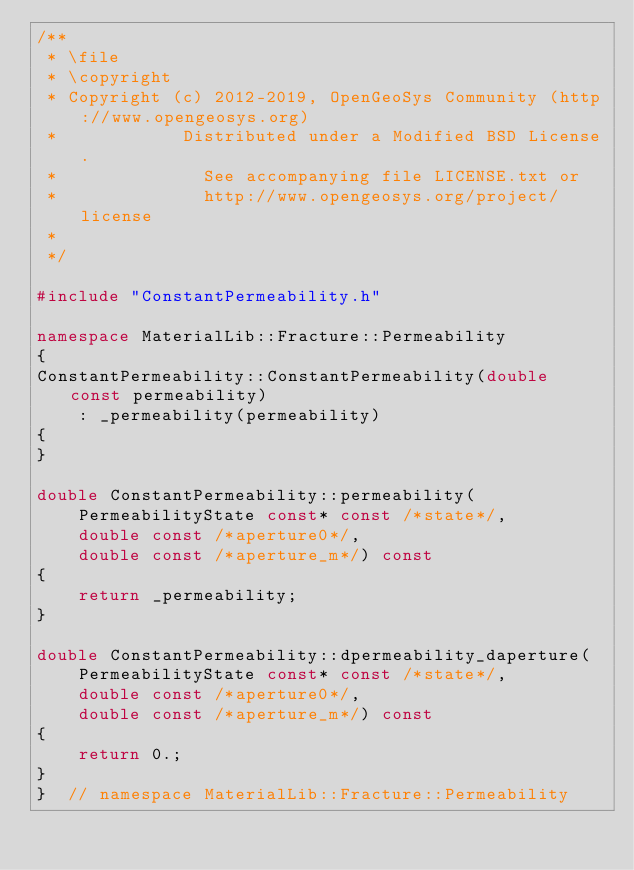Convert code to text. <code><loc_0><loc_0><loc_500><loc_500><_C++_>/**
 * \file
 * \copyright
 * Copyright (c) 2012-2019, OpenGeoSys Community (http://www.opengeosys.org)
 *            Distributed under a Modified BSD License.
 *              See accompanying file LICENSE.txt or
 *              http://www.opengeosys.org/project/license
 *
 */

#include "ConstantPermeability.h"

namespace MaterialLib::Fracture::Permeability
{
ConstantPermeability::ConstantPermeability(double const permeability)
    : _permeability(permeability)
{
}

double ConstantPermeability::permeability(
    PermeabilityState const* const /*state*/,
    double const /*aperture0*/,
    double const /*aperture_m*/) const
{
    return _permeability;
}

double ConstantPermeability::dpermeability_daperture(
    PermeabilityState const* const /*state*/,
    double const /*aperture0*/,
    double const /*aperture_m*/) const
{
    return 0.;
}
}  // namespace MaterialLib::Fracture::Permeability
</code> 